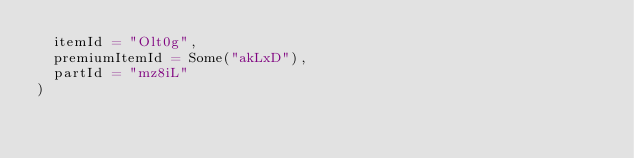Convert code to text. <code><loc_0><loc_0><loc_500><loc_500><_Scala_>  itemId = "Olt0g",
  premiumItemId = Some("akLxD"),
  partId = "mz8iL"
)
</code> 